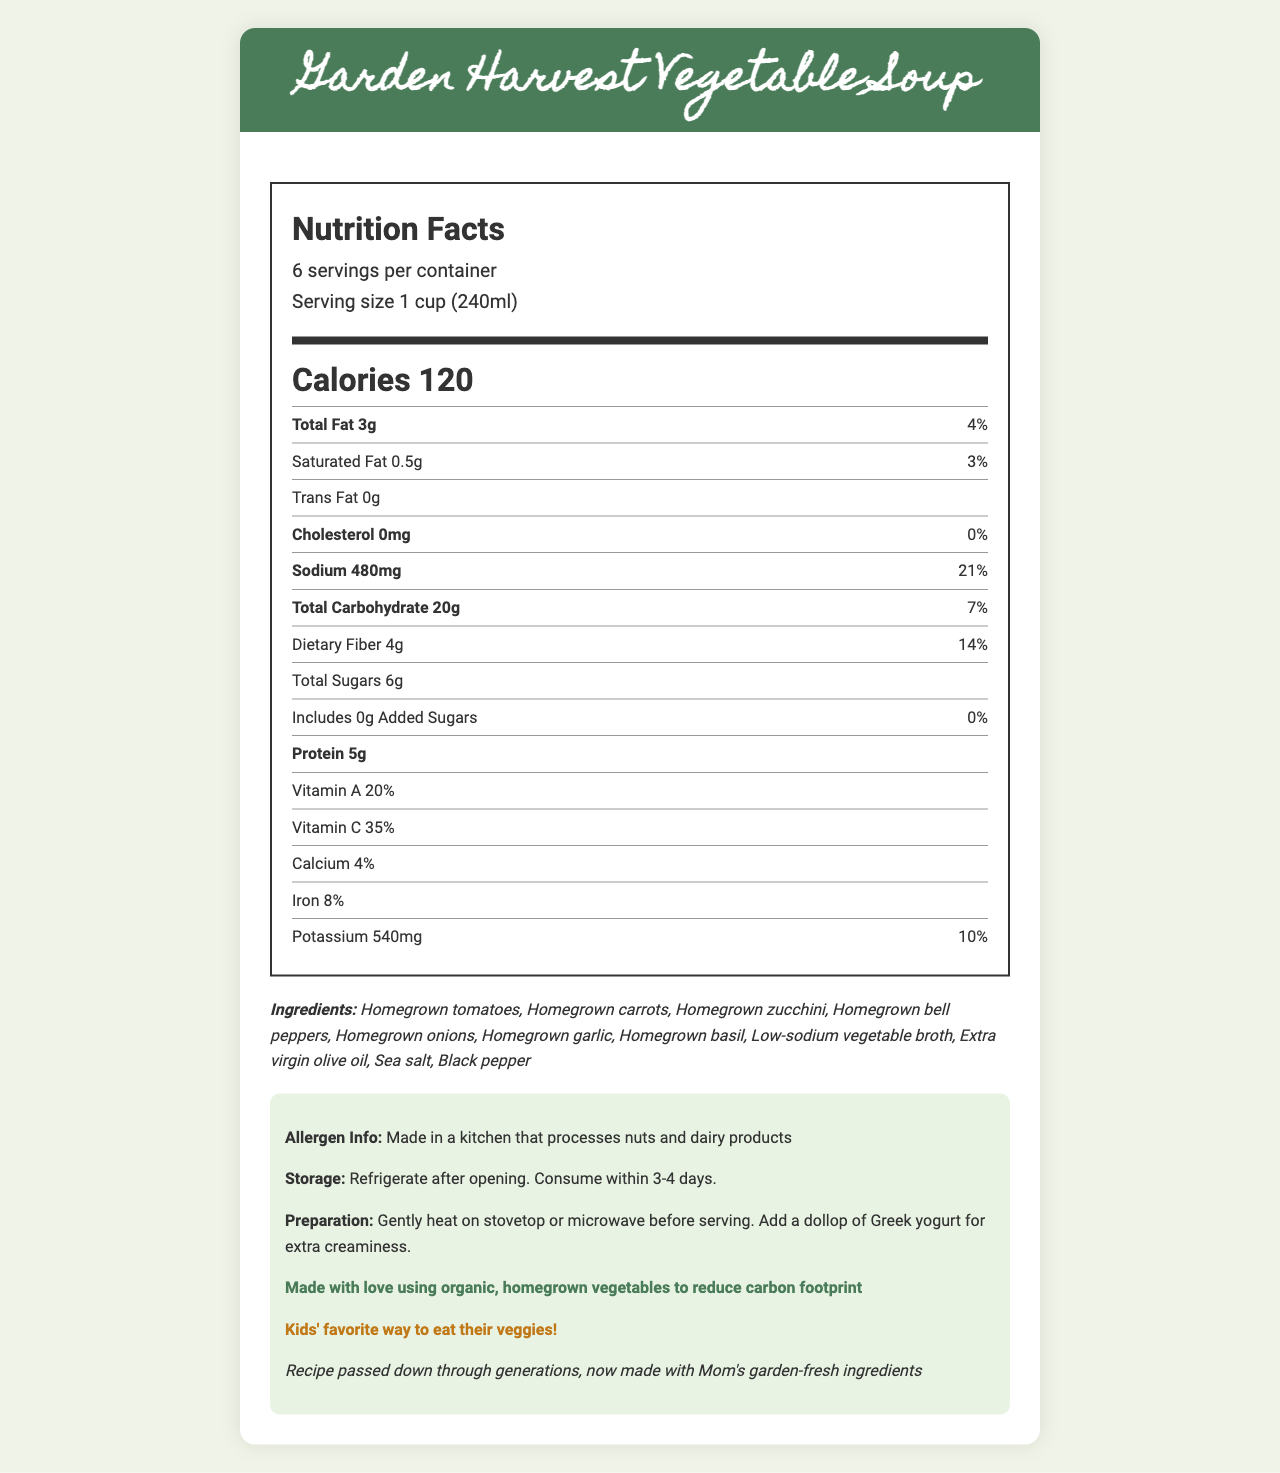what is the product name? The product name is indicated at the top of the document and in the header section.
Answer: Garden Harvest Vegetable Soup how many servings are in a container? It is mentioned in the serving information section of the nutrition label.
Answer: 6 what is the serving size? This information can be found in the serving size details of the nutrition label.
Answer: 1 cup (240ml) how many calories are there per serving? The calories per serving are prominently listed in the calories section of the document.
Answer: 120 how much sodium is in one serving? The sodium content per serving is listed in the nutrient row section under sodium.
Answer: 480 mg which vitamins does this soup contain? A. Vitamin A and Vitamin C B. Vitamin B and Vitamin D C. Vitamin E and Vitamin K Vitamin A and Vitamin C are listed in the nutrient row section, while Vitamin B, Vitamin D, Vitamin E, and Vitamin K are not mentioned.
Answer: A which ingredient is not included in the soup? A. Homegrown carrots B. Homegrown zucchini C. Homegrown potatoes The ingredients list includes homegrown carrots and homegrown zucchini but does not mention homegrown potatoes.
Answer: C is this soup high in protein? The soup has 5g of protein per serving, which is not considered high protein.
Answer: No does this soup contain any added sugars? The document states that the soup includes 0g of added sugars.
Answer: No describe the main idea of the document The document includes a nutrition label, an ingredient list, allergen information, storage instructions, preparation tips, and additional notes about sustainability and family-friendliness.
Answer: The document provides detailed nutrition facts, ingredients, and additional information about Garden Harvest Vegetable Soup, emphasizing its use of homegrown organic vegetables and family-friendly features. how much dietary fiber does one serving contain? The dietary fiber content is listed in the nutrient row section under dietary fiber.
Answer: 4g can this soup be consumed by someone with a nut allergy? The allergen information states that the product is made in a kitchen that processes nuts, indicating possible cross-contamination.
Answer: Not necessarily what type of oil is used in this soup? Extra virgin olive oil is listed as one of the ingredients.
Answer: Extra virgin olive oil is the soup high in calcium? The soup contains 4% of the daily value of calcium, which is not considered high.
Answer: No how should this soup be stored after opening? The storage instructions provide details on how to store the soup.
Answer: Refrigerate after opening. Consume within 3-4 days. how does the document emphasize sustainability? This note is highlighted in the additional information section under sustainability.
Answer: Made with love using organic, homegrown vegetables to reduce carbon footprint when was this recipe passed down? The document indicates that the recipe was passed down through generations but does not specify when exactly.
Answer: Not enough information what does the label suggest adding for extra creaminess? The preparation tips recommend adding a dollop of Greek yogurt for extra creaminess.
Answer: A dollop of Greek yogurt 